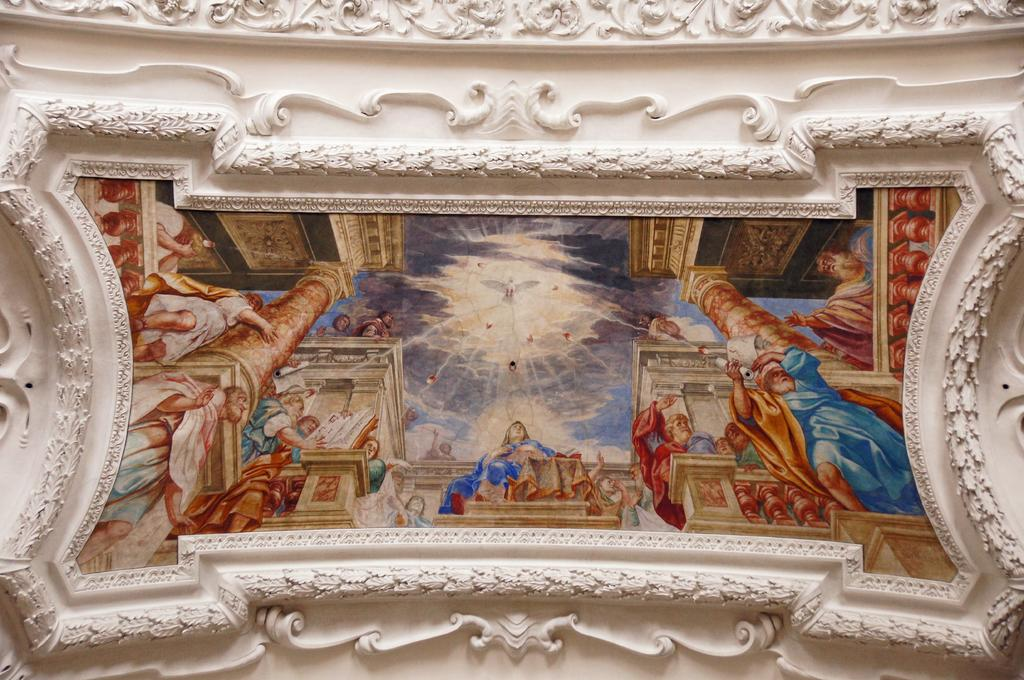What can be seen on the wall in the image? There is a photo frame placed on the wall. Are there any other decorative elements on the wall? Yes, there are carvings on the wall. How does the bee interact with the carvings on the wall in the image? There is no bee present in the image, so it cannot interact with the carvings on the wall. 